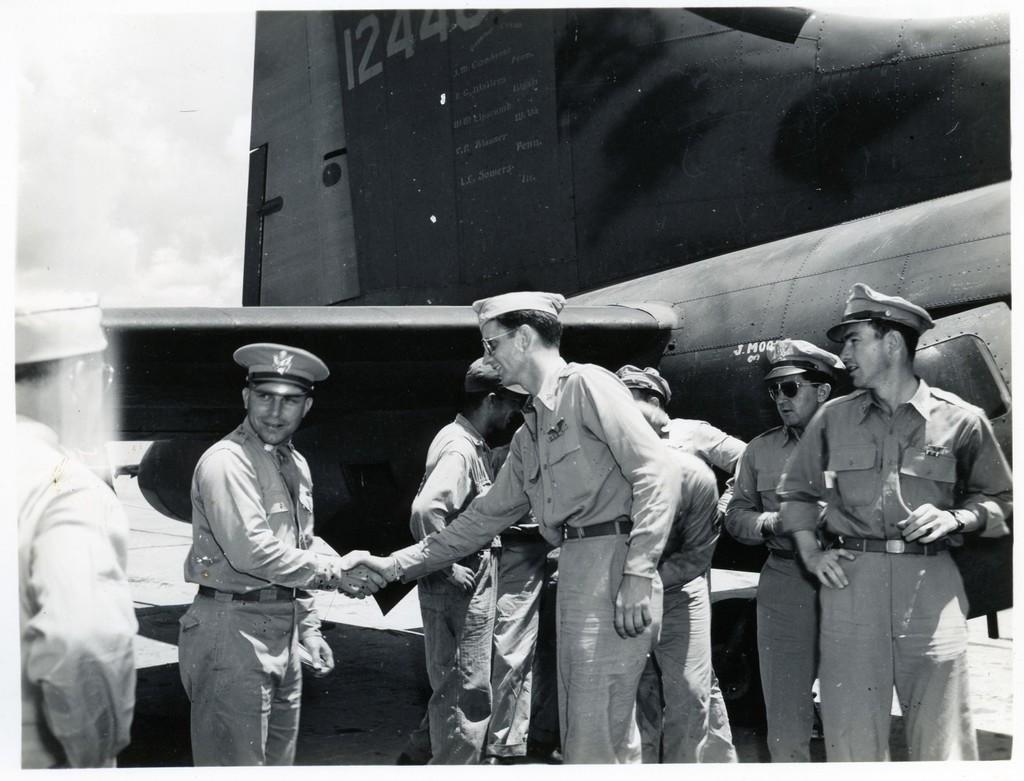Provide a one-sentence caption for the provided image. Lt Sowers engraved on a gray airplane and W.W Lipscomb above it. 